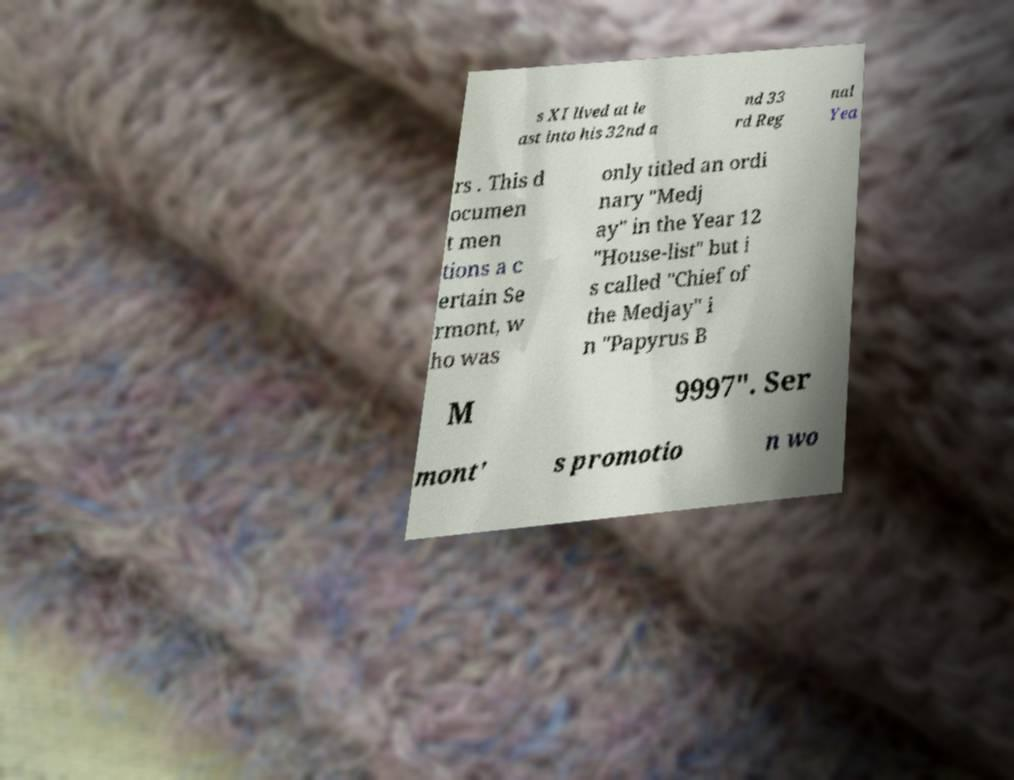Please identify and transcribe the text found in this image. s XI lived at le ast into his 32nd a nd 33 rd Reg nal Yea rs . This d ocumen t men tions a c ertain Se rmont, w ho was only titled an ordi nary "Medj ay" in the Year 12 "House-list" but i s called "Chief of the Medjay" i n "Papyrus B M 9997". Ser mont' s promotio n wo 